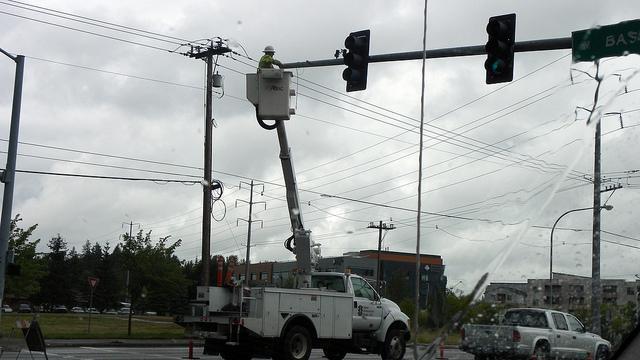How many trucks are there?
Give a very brief answer. 2. How many trucks are in the photo?
Give a very brief answer. 2. How many horses are in the picture?
Give a very brief answer. 0. 